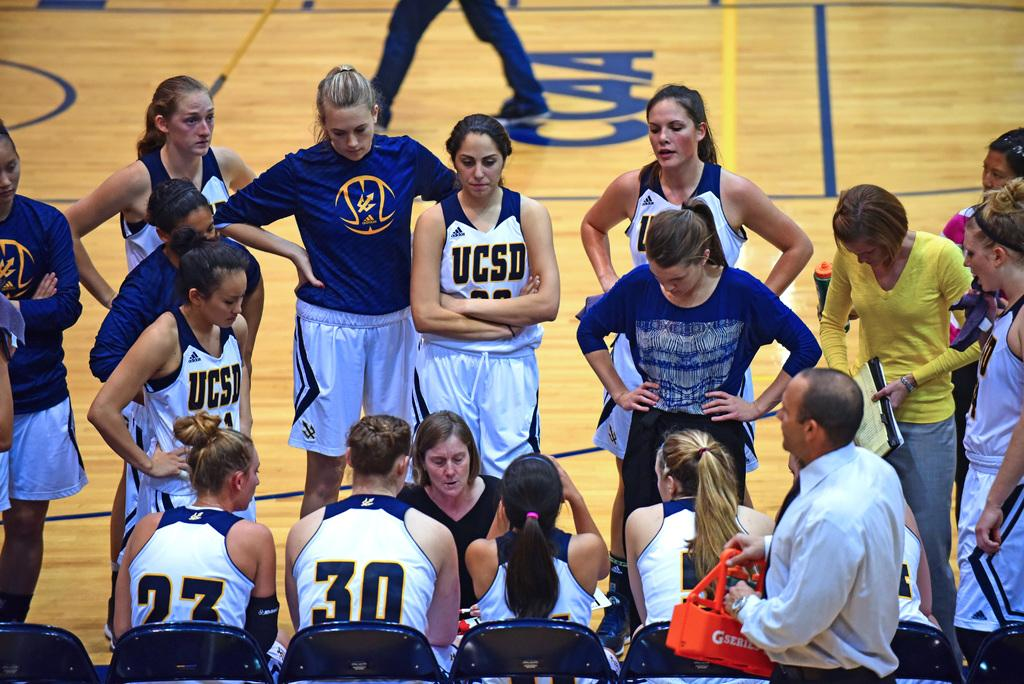<image>
Present a compact description of the photo's key features. basketball players standing on the court with USCD on their jerseys 